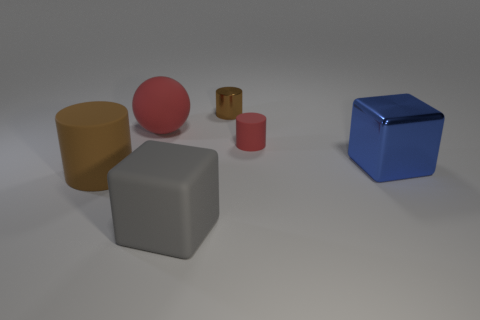What color is the large object that is to the right of the metal thing that is to the left of the blue block?
Keep it short and to the point. Blue. Is there a metal cylinder that has the same color as the large rubber sphere?
Your answer should be compact. No. How big is the matte object that is left of the red thing that is behind the red rubber thing to the right of the large gray thing?
Keep it short and to the point. Large. The large gray object has what shape?
Your answer should be compact. Cube. There is a matte thing that is the same color as the ball; what is its size?
Ensure brevity in your answer.  Small. There is a large cube that is on the left side of the large metallic cube; how many brown rubber cylinders are behind it?
Make the answer very short. 1. How many other objects are the same material as the large red ball?
Offer a very short reply. 3. Does the red object left of the large gray matte object have the same material as the large cube that is behind the large brown matte cylinder?
Keep it short and to the point. No. Is there anything else that is the same shape as the small rubber thing?
Provide a short and direct response. Yes. Does the large blue thing have the same material as the cylinder on the left side of the tiny metallic cylinder?
Offer a terse response. No. 